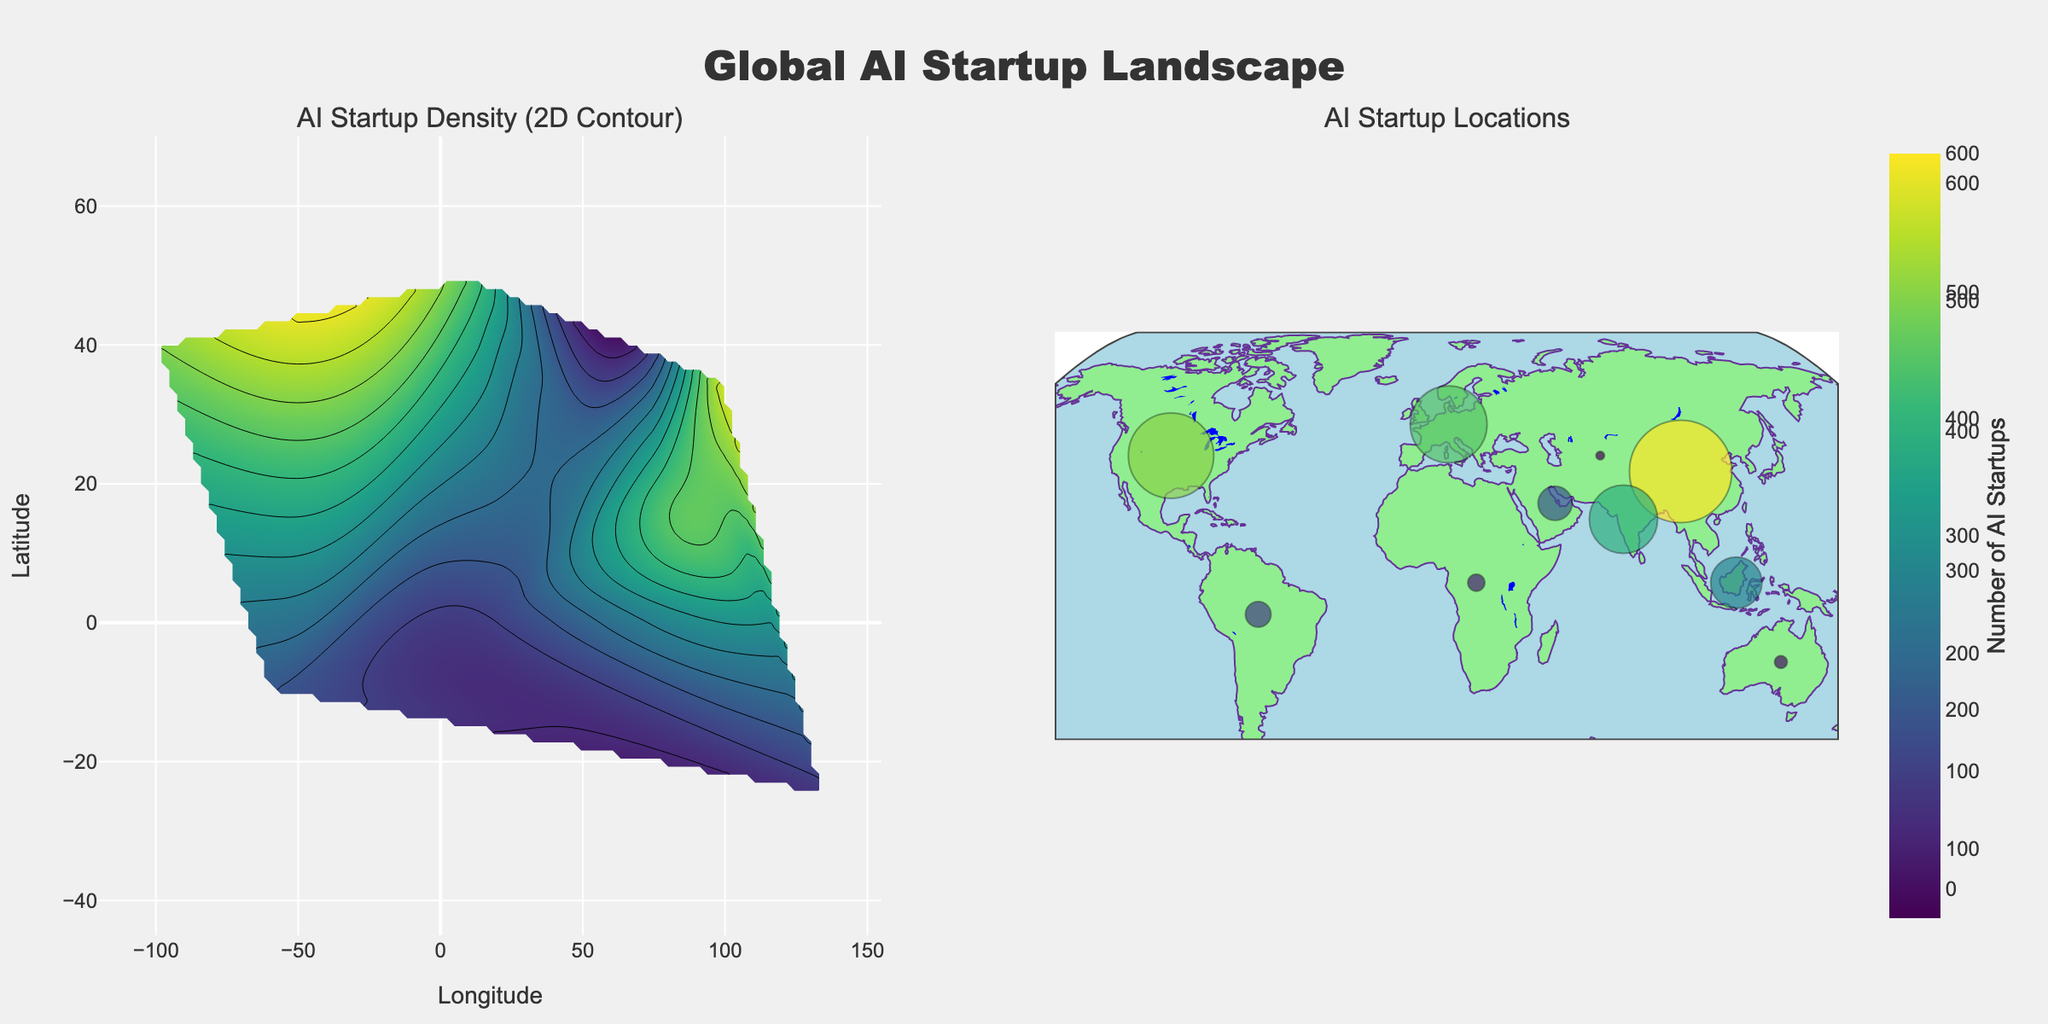What's the title of the figure? Look at the top of the figure where the title is usually placed.
Answer: "Global AI Startup Landscape" What is the range for the number of AI startups indicated by the colorbar? Examine the colorbar on the right side of the contour plot to identify the minimum and maximum values.
Answer: 0 to 600 Which region has the highest density of AI startups? Look at the region with the highest contour color intensity in the 2D contour plot or the largest marker size in the scatter plot.
Answer: Asia What are the coordinates with the highest concentration of AI startups in North America? Refer to the location of North America in the scatter plot and note its coordinates.
Answer: Longitude: -100, Latitude: 40 Compare the number of AI startups in Europe and South America. Which has more, and by how much? Look at the scatter plot and check the values associated with Europe and South America. Subtract the AI startups in South America from those in Europe.
Answer: Europe has 300 more AI startups How does the density of AI startups in Africa compare to Southeast Asia? Compare the color intensity for Africa and Southeast Asia in the 2D contour plot as well as the marker sizes in the scatter plot.
Answer: Southeast Asia has a higher density Is there a noticeable pattern in AI startup distribution across continents? Assess the overall distribution in both plots, noting concentrations and sparsely populated regions.
Answer: High densities in Asia and North America, lower densities in Africa and Australia Determine the median number of AI startups among the given regions. List the AI startup numbers: 500, 450, 600, 150, 100, 75, 200, 300, 50, 400. Sort them and find the middle value(s). With 10 values, median is the average of 5th and 6th values.
Answer: Median is 275 Which region has the smallest number of AI startups and what is the count? Identify the data point with the smallest value in the scatter plot or color intensity in the contour plot.
Answer: Australia with 75 AI startups What does the color "LightGreen" represent in the scatter plot? Observe the background and legend to determine what "LightGreen" is used for in the scatter plot.
Answer: Represents land areas 